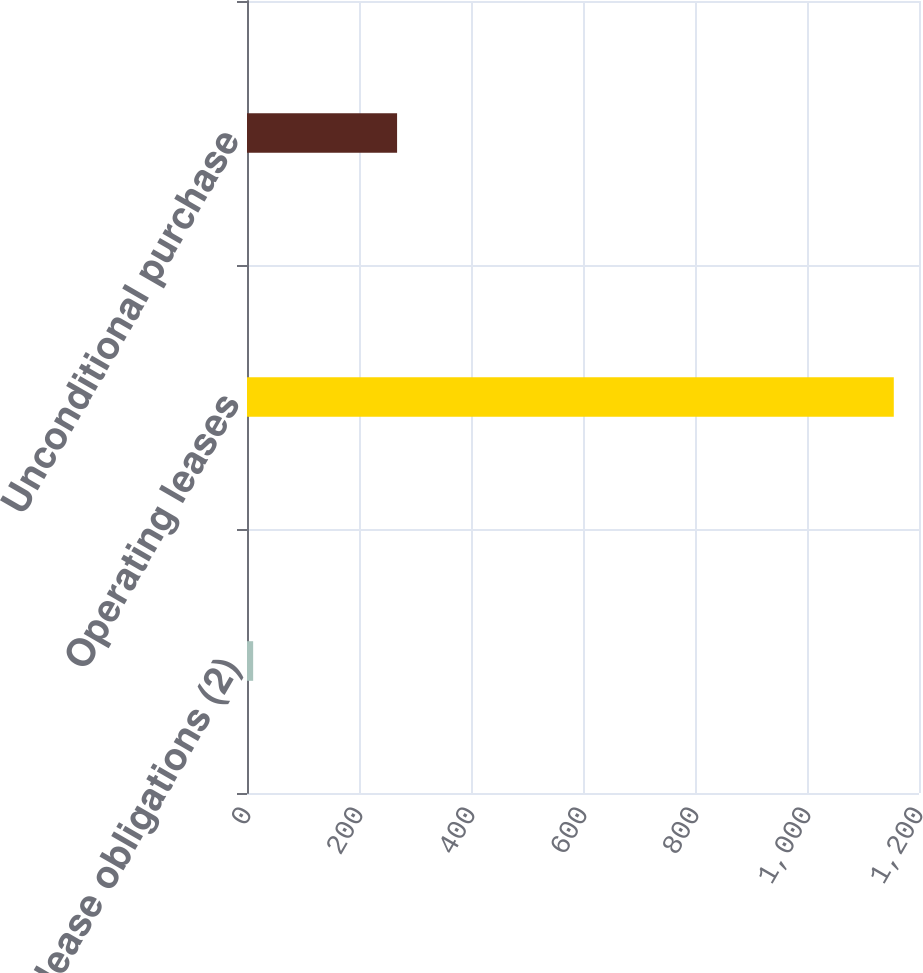Convert chart to OTSL. <chart><loc_0><loc_0><loc_500><loc_500><bar_chart><fcel>Capital lease obligations (2)<fcel>Operating leases<fcel>Unconditional purchase<nl><fcel>11<fcel>1155<fcel>268<nl></chart> 